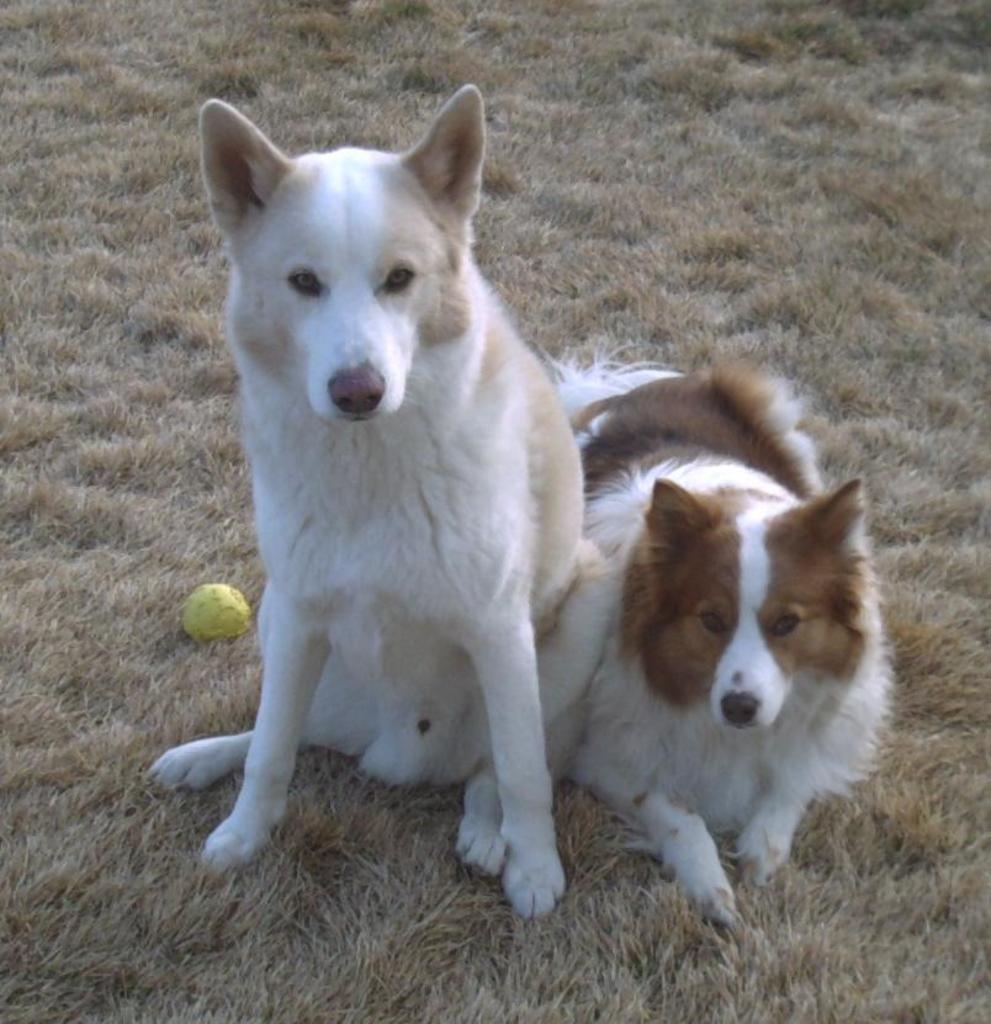How would you summarize this image in a sentence or two? In this image there are two dogs and a ball on the grass. 